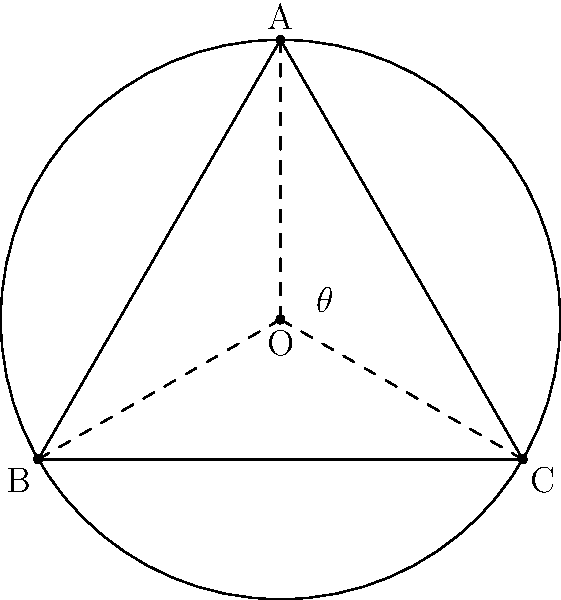As a retired conductor, you've been asked to consult on the design of a new circular amphitheater. The architects want to ensure optimal sound distribution by placing three main speakers at equal angles around the perimeter. If the amphitheater has a radius of 50 meters, and the angle between each speaker is $\theta$, what is the straight-line distance between any two adjacent speakers? Round your answer to the nearest meter. Let's approach this step-by-step:

1) First, we need to recognize that the speakers form an equilateral triangle inscribed in the circle of the amphitheater.

2) The angle between each speaker, $\theta$, is one-third of a full circle:
   $$\theta = \frac{360°}{3} = 120°$$

3) The straight-line distance between two speakers is a chord of the circle. We can find this using the chord length formula:
   $$\text{chord length} = 2R \sin(\frac{\theta}{2})$$
   where $R$ is the radius of the circle.

4) Let's substitute our values:
   $$\text{chord length} = 2 \cdot 50 \cdot \sin(\frac{120°}{2})$$

5) Simplify:
   $$\text{chord length} = 100 \cdot \sin(60°)$$

6) We know that $\sin(60°) = \frac{\sqrt{3}}{2}$, so:
   $$\text{chord length} = 100 \cdot \frac{\sqrt{3}}{2} = 50\sqrt{3}$$

7) Calculate and round to the nearest meter:
   $$50\sqrt{3} \approx 86.60 \approx 87 \text{ meters}$$
Answer: 87 meters 